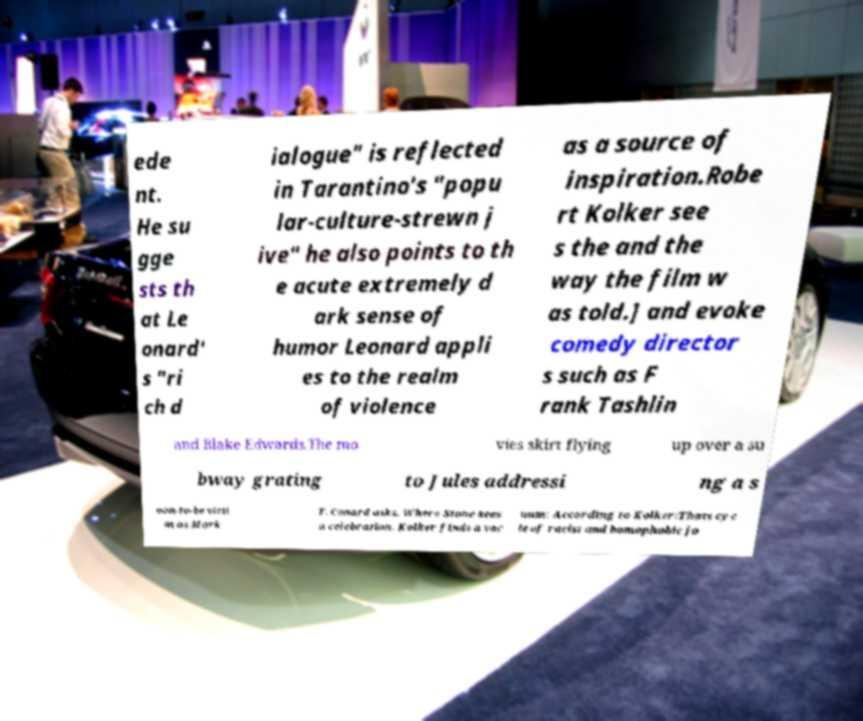Please read and relay the text visible in this image. What does it say? ede nt. He su gge sts th at Le onard' s "ri ch d ialogue" is reflected in Tarantino's "popu lar-culture-strewn j ive" he also points to th e acute extremely d ark sense of humor Leonard appli es to the realm of violence as a source of inspiration.Robe rt Kolker see s the and the way the film w as told.] and evoke comedy director s such as F rank Tashlin and Blake Edwards.The mo vies skirt flying up over a su bway grating to Jules addressi ng a s oon-to-be victi m as Mark T. Conard asks, Where Stone sees a celebration, Kolker finds a vac uum: According to Kolker:Thats cyc le of racist and homophobic jo 